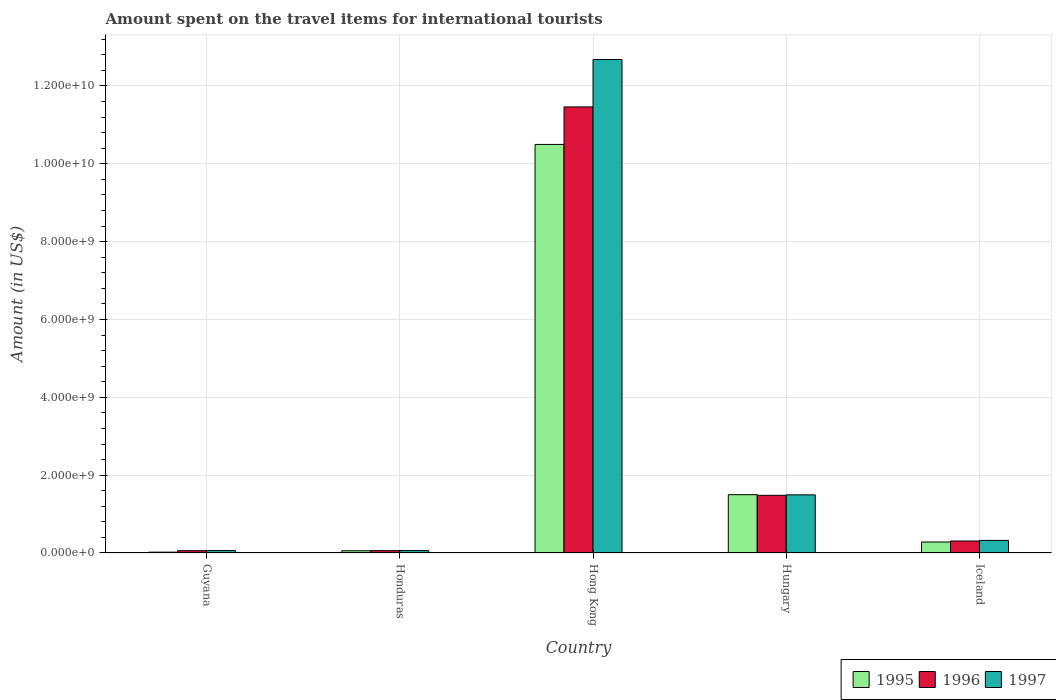How many different coloured bars are there?
Offer a terse response. 3. Are the number of bars on each tick of the X-axis equal?
Your answer should be compact. Yes. How many bars are there on the 4th tick from the left?
Make the answer very short. 3. How many bars are there on the 2nd tick from the right?
Ensure brevity in your answer.  3. What is the label of the 4th group of bars from the left?
Give a very brief answer. Hungary. What is the amount spent on the travel items for international tourists in 1996 in Hungary?
Offer a terse response. 1.48e+09. Across all countries, what is the maximum amount spent on the travel items for international tourists in 1997?
Offer a very short reply. 1.27e+1. Across all countries, what is the minimum amount spent on the travel items for international tourists in 1995?
Provide a short and direct response. 2.10e+07. In which country was the amount spent on the travel items for international tourists in 1996 maximum?
Keep it short and to the point. Hong Kong. In which country was the amount spent on the travel items for international tourists in 1995 minimum?
Your answer should be compact. Guyana. What is the total amount spent on the travel items for international tourists in 1997 in the graph?
Provide a succinct answer. 1.46e+1. What is the difference between the amount spent on the travel items for international tourists in 1996 in Hong Kong and that in Iceland?
Make the answer very short. 1.12e+1. What is the difference between the amount spent on the travel items for international tourists in 1995 in Iceland and the amount spent on the travel items for international tourists in 1996 in Hong Kong?
Your answer should be compact. -1.12e+1. What is the average amount spent on the travel items for international tourists in 1995 per country?
Your answer should be very brief. 2.47e+09. What is the difference between the amount spent on the travel items for international tourists of/in 1997 and amount spent on the travel items for international tourists of/in 1995 in Hungary?
Your answer should be compact. -4.00e+06. In how many countries, is the amount spent on the travel items for international tourists in 1995 greater than 4400000000 US$?
Provide a short and direct response. 1. What is the ratio of the amount spent on the travel items for international tourists in 1996 in Guyana to that in Honduras?
Keep it short and to the point. 0.98. Is the amount spent on the travel items for international tourists in 1995 in Honduras less than that in Hong Kong?
Ensure brevity in your answer.  Yes. What is the difference between the highest and the second highest amount spent on the travel items for international tourists in 1995?
Provide a short and direct response. 9.00e+09. What is the difference between the highest and the lowest amount spent on the travel items for international tourists in 1997?
Offer a terse response. 1.26e+1. In how many countries, is the amount spent on the travel items for international tourists in 1997 greater than the average amount spent on the travel items for international tourists in 1997 taken over all countries?
Offer a very short reply. 1. What does the 3rd bar from the left in Hong Kong represents?
Offer a very short reply. 1997. What does the 1st bar from the right in Guyana represents?
Provide a succinct answer. 1997. Are all the bars in the graph horizontal?
Your answer should be very brief. No. What is the difference between two consecutive major ticks on the Y-axis?
Keep it short and to the point. 2.00e+09. Does the graph contain any zero values?
Offer a terse response. No. Does the graph contain grids?
Offer a very short reply. Yes. What is the title of the graph?
Ensure brevity in your answer.  Amount spent on the travel items for international tourists. What is the Amount (in US$) of 1995 in Guyana?
Give a very brief answer. 2.10e+07. What is the Amount (in US$) of 1996 in Guyana?
Provide a short and direct response. 5.90e+07. What is the Amount (in US$) of 1997 in Guyana?
Your response must be concise. 6.20e+07. What is the Amount (in US$) in 1995 in Honduras?
Ensure brevity in your answer.  5.70e+07. What is the Amount (in US$) of 1996 in Honduras?
Keep it short and to the point. 6.00e+07. What is the Amount (in US$) in 1997 in Honduras?
Ensure brevity in your answer.  6.20e+07. What is the Amount (in US$) of 1995 in Hong Kong?
Give a very brief answer. 1.05e+1. What is the Amount (in US$) of 1996 in Hong Kong?
Your answer should be compact. 1.15e+1. What is the Amount (in US$) of 1997 in Hong Kong?
Keep it short and to the point. 1.27e+1. What is the Amount (in US$) in 1995 in Hungary?
Your answer should be compact. 1.50e+09. What is the Amount (in US$) of 1996 in Hungary?
Provide a succinct answer. 1.48e+09. What is the Amount (in US$) in 1997 in Hungary?
Keep it short and to the point. 1.49e+09. What is the Amount (in US$) of 1995 in Iceland?
Make the answer very short. 2.82e+08. What is the Amount (in US$) of 1996 in Iceland?
Make the answer very short. 3.08e+08. What is the Amount (in US$) in 1997 in Iceland?
Your response must be concise. 3.23e+08. Across all countries, what is the maximum Amount (in US$) in 1995?
Make the answer very short. 1.05e+1. Across all countries, what is the maximum Amount (in US$) of 1996?
Offer a very short reply. 1.15e+1. Across all countries, what is the maximum Amount (in US$) of 1997?
Your answer should be compact. 1.27e+1. Across all countries, what is the minimum Amount (in US$) in 1995?
Your response must be concise. 2.10e+07. Across all countries, what is the minimum Amount (in US$) of 1996?
Ensure brevity in your answer.  5.90e+07. Across all countries, what is the minimum Amount (in US$) of 1997?
Your answer should be compact. 6.20e+07. What is the total Amount (in US$) in 1995 in the graph?
Offer a very short reply. 1.24e+1. What is the total Amount (in US$) of 1996 in the graph?
Provide a short and direct response. 1.34e+1. What is the total Amount (in US$) in 1997 in the graph?
Your answer should be compact. 1.46e+1. What is the difference between the Amount (in US$) of 1995 in Guyana and that in Honduras?
Your answer should be compact. -3.60e+07. What is the difference between the Amount (in US$) in 1996 in Guyana and that in Honduras?
Ensure brevity in your answer.  -1.00e+06. What is the difference between the Amount (in US$) in 1995 in Guyana and that in Hong Kong?
Your response must be concise. -1.05e+1. What is the difference between the Amount (in US$) in 1996 in Guyana and that in Hong Kong?
Ensure brevity in your answer.  -1.14e+1. What is the difference between the Amount (in US$) of 1997 in Guyana and that in Hong Kong?
Give a very brief answer. -1.26e+1. What is the difference between the Amount (in US$) in 1995 in Guyana and that in Hungary?
Make the answer very short. -1.48e+09. What is the difference between the Amount (in US$) of 1996 in Guyana and that in Hungary?
Provide a short and direct response. -1.42e+09. What is the difference between the Amount (in US$) of 1997 in Guyana and that in Hungary?
Make the answer very short. -1.43e+09. What is the difference between the Amount (in US$) of 1995 in Guyana and that in Iceland?
Make the answer very short. -2.61e+08. What is the difference between the Amount (in US$) of 1996 in Guyana and that in Iceland?
Give a very brief answer. -2.49e+08. What is the difference between the Amount (in US$) of 1997 in Guyana and that in Iceland?
Your answer should be very brief. -2.61e+08. What is the difference between the Amount (in US$) in 1995 in Honduras and that in Hong Kong?
Ensure brevity in your answer.  -1.04e+1. What is the difference between the Amount (in US$) in 1996 in Honduras and that in Hong Kong?
Offer a terse response. -1.14e+1. What is the difference between the Amount (in US$) of 1997 in Honduras and that in Hong Kong?
Provide a short and direct response. -1.26e+1. What is the difference between the Amount (in US$) in 1995 in Honduras and that in Hungary?
Provide a short and direct response. -1.44e+09. What is the difference between the Amount (in US$) of 1996 in Honduras and that in Hungary?
Give a very brief answer. -1.42e+09. What is the difference between the Amount (in US$) of 1997 in Honduras and that in Hungary?
Your answer should be compact. -1.43e+09. What is the difference between the Amount (in US$) in 1995 in Honduras and that in Iceland?
Make the answer very short. -2.25e+08. What is the difference between the Amount (in US$) in 1996 in Honduras and that in Iceland?
Give a very brief answer. -2.48e+08. What is the difference between the Amount (in US$) of 1997 in Honduras and that in Iceland?
Give a very brief answer. -2.61e+08. What is the difference between the Amount (in US$) of 1995 in Hong Kong and that in Hungary?
Provide a short and direct response. 9.00e+09. What is the difference between the Amount (in US$) of 1996 in Hong Kong and that in Hungary?
Keep it short and to the point. 9.98e+09. What is the difference between the Amount (in US$) in 1997 in Hong Kong and that in Hungary?
Provide a short and direct response. 1.12e+1. What is the difference between the Amount (in US$) in 1995 in Hong Kong and that in Iceland?
Make the answer very short. 1.02e+1. What is the difference between the Amount (in US$) in 1996 in Hong Kong and that in Iceland?
Offer a terse response. 1.12e+1. What is the difference between the Amount (in US$) of 1997 in Hong Kong and that in Iceland?
Your response must be concise. 1.24e+1. What is the difference between the Amount (in US$) of 1995 in Hungary and that in Iceland?
Give a very brief answer. 1.22e+09. What is the difference between the Amount (in US$) in 1996 in Hungary and that in Iceland?
Make the answer very short. 1.17e+09. What is the difference between the Amount (in US$) of 1997 in Hungary and that in Iceland?
Your answer should be compact. 1.17e+09. What is the difference between the Amount (in US$) of 1995 in Guyana and the Amount (in US$) of 1996 in Honduras?
Make the answer very short. -3.90e+07. What is the difference between the Amount (in US$) of 1995 in Guyana and the Amount (in US$) of 1997 in Honduras?
Offer a terse response. -4.10e+07. What is the difference between the Amount (in US$) of 1996 in Guyana and the Amount (in US$) of 1997 in Honduras?
Offer a very short reply. -3.00e+06. What is the difference between the Amount (in US$) in 1995 in Guyana and the Amount (in US$) in 1996 in Hong Kong?
Provide a short and direct response. -1.14e+1. What is the difference between the Amount (in US$) of 1995 in Guyana and the Amount (in US$) of 1997 in Hong Kong?
Your answer should be compact. -1.27e+1. What is the difference between the Amount (in US$) of 1996 in Guyana and the Amount (in US$) of 1997 in Hong Kong?
Offer a very short reply. -1.26e+1. What is the difference between the Amount (in US$) in 1995 in Guyana and the Amount (in US$) in 1996 in Hungary?
Keep it short and to the point. -1.46e+09. What is the difference between the Amount (in US$) in 1995 in Guyana and the Amount (in US$) in 1997 in Hungary?
Provide a succinct answer. -1.47e+09. What is the difference between the Amount (in US$) of 1996 in Guyana and the Amount (in US$) of 1997 in Hungary?
Provide a succinct answer. -1.44e+09. What is the difference between the Amount (in US$) of 1995 in Guyana and the Amount (in US$) of 1996 in Iceland?
Make the answer very short. -2.87e+08. What is the difference between the Amount (in US$) in 1995 in Guyana and the Amount (in US$) in 1997 in Iceland?
Ensure brevity in your answer.  -3.02e+08. What is the difference between the Amount (in US$) in 1996 in Guyana and the Amount (in US$) in 1997 in Iceland?
Ensure brevity in your answer.  -2.64e+08. What is the difference between the Amount (in US$) in 1995 in Honduras and the Amount (in US$) in 1996 in Hong Kong?
Provide a short and direct response. -1.14e+1. What is the difference between the Amount (in US$) of 1995 in Honduras and the Amount (in US$) of 1997 in Hong Kong?
Your answer should be compact. -1.26e+1. What is the difference between the Amount (in US$) of 1996 in Honduras and the Amount (in US$) of 1997 in Hong Kong?
Provide a short and direct response. -1.26e+1. What is the difference between the Amount (in US$) of 1995 in Honduras and the Amount (in US$) of 1996 in Hungary?
Make the answer very short. -1.42e+09. What is the difference between the Amount (in US$) of 1995 in Honduras and the Amount (in US$) of 1997 in Hungary?
Offer a very short reply. -1.44e+09. What is the difference between the Amount (in US$) of 1996 in Honduras and the Amount (in US$) of 1997 in Hungary?
Give a very brief answer. -1.43e+09. What is the difference between the Amount (in US$) of 1995 in Honduras and the Amount (in US$) of 1996 in Iceland?
Keep it short and to the point. -2.51e+08. What is the difference between the Amount (in US$) in 1995 in Honduras and the Amount (in US$) in 1997 in Iceland?
Ensure brevity in your answer.  -2.66e+08. What is the difference between the Amount (in US$) in 1996 in Honduras and the Amount (in US$) in 1997 in Iceland?
Your answer should be compact. -2.63e+08. What is the difference between the Amount (in US$) in 1995 in Hong Kong and the Amount (in US$) in 1996 in Hungary?
Give a very brief answer. 9.02e+09. What is the difference between the Amount (in US$) in 1995 in Hong Kong and the Amount (in US$) in 1997 in Hungary?
Give a very brief answer. 9.00e+09. What is the difference between the Amount (in US$) of 1996 in Hong Kong and the Amount (in US$) of 1997 in Hungary?
Make the answer very short. 9.97e+09. What is the difference between the Amount (in US$) of 1995 in Hong Kong and the Amount (in US$) of 1996 in Iceland?
Keep it short and to the point. 1.02e+1. What is the difference between the Amount (in US$) in 1995 in Hong Kong and the Amount (in US$) in 1997 in Iceland?
Your answer should be compact. 1.02e+1. What is the difference between the Amount (in US$) of 1996 in Hong Kong and the Amount (in US$) of 1997 in Iceland?
Provide a short and direct response. 1.11e+1. What is the difference between the Amount (in US$) in 1995 in Hungary and the Amount (in US$) in 1996 in Iceland?
Make the answer very short. 1.19e+09. What is the difference between the Amount (in US$) of 1995 in Hungary and the Amount (in US$) of 1997 in Iceland?
Offer a very short reply. 1.18e+09. What is the difference between the Amount (in US$) of 1996 in Hungary and the Amount (in US$) of 1997 in Iceland?
Offer a very short reply. 1.16e+09. What is the average Amount (in US$) in 1995 per country?
Your answer should be very brief. 2.47e+09. What is the average Amount (in US$) in 1996 per country?
Your response must be concise. 2.67e+09. What is the average Amount (in US$) of 1997 per country?
Keep it short and to the point. 2.92e+09. What is the difference between the Amount (in US$) of 1995 and Amount (in US$) of 1996 in Guyana?
Your answer should be compact. -3.80e+07. What is the difference between the Amount (in US$) in 1995 and Amount (in US$) in 1997 in Guyana?
Make the answer very short. -4.10e+07. What is the difference between the Amount (in US$) in 1996 and Amount (in US$) in 1997 in Guyana?
Keep it short and to the point. -3.00e+06. What is the difference between the Amount (in US$) in 1995 and Amount (in US$) in 1996 in Honduras?
Provide a succinct answer. -3.00e+06. What is the difference between the Amount (in US$) of 1995 and Amount (in US$) of 1997 in Honduras?
Give a very brief answer. -5.00e+06. What is the difference between the Amount (in US$) in 1996 and Amount (in US$) in 1997 in Honduras?
Offer a terse response. -2.00e+06. What is the difference between the Amount (in US$) in 1995 and Amount (in US$) in 1996 in Hong Kong?
Provide a succinct answer. -9.64e+08. What is the difference between the Amount (in US$) of 1995 and Amount (in US$) of 1997 in Hong Kong?
Offer a terse response. -2.18e+09. What is the difference between the Amount (in US$) in 1996 and Amount (in US$) in 1997 in Hong Kong?
Ensure brevity in your answer.  -1.22e+09. What is the difference between the Amount (in US$) of 1995 and Amount (in US$) of 1996 in Hungary?
Ensure brevity in your answer.  1.60e+07. What is the difference between the Amount (in US$) of 1996 and Amount (in US$) of 1997 in Hungary?
Give a very brief answer. -1.20e+07. What is the difference between the Amount (in US$) in 1995 and Amount (in US$) in 1996 in Iceland?
Keep it short and to the point. -2.60e+07. What is the difference between the Amount (in US$) in 1995 and Amount (in US$) in 1997 in Iceland?
Keep it short and to the point. -4.10e+07. What is the difference between the Amount (in US$) in 1996 and Amount (in US$) in 1997 in Iceland?
Offer a very short reply. -1.50e+07. What is the ratio of the Amount (in US$) of 1995 in Guyana to that in Honduras?
Keep it short and to the point. 0.37. What is the ratio of the Amount (in US$) of 1996 in Guyana to that in Honduras?
Give a very brief answer. 0.98. What is the ratio of the Amount (in US$) in 1997 in Guyana to that in Honduras?
Offer a very short reply. 1. What is the ratio of the Amount (in US$) in 1995 in Guyana to that in Hong Kong?
Give a very brief answer. 0. What is the ratio of the Amount (in US$) of 1996 in Guyana to that in Hong Kong?
Give a very brief answer. 0.01. What is the ratio of the Amount (in US$) in 1997 in Guyana to that in Hong Kong?
Offer a terse response. 0. What is the ratio of the Amount (in US$) of 1995 in Guyana to that in Hungary?
Offer a terse response. 0.01. What is the ratio of the Amount (in US$) of 1996 in Guyana to that in Hungary?
Offer a terse response. 0.04. What is the ratio of the Amount (in US$) of 1997 in Guyana to that in Hungary?
Offer a very short reply. 0.04. What is the ratio of the Amount (in US$) of 1995 in Guyana to that in Iceland?
Your answer should be compact. 0.07. What is the ratio of the Amount (in US$) in 1996 in Guyana to that in Iceland?
Keep it short and to the point. 0.19. What is the ratio of the Amount (in US$) of 1997 in Guyana to that in Iceland?
Your response must be concise. 0.19. What is the ratio of the Amount (in US$) of 1995 in Honduras to that in Hong Kong?
Provide a short and direct response. 0.01. What is the ratio of the Amount (in US$) of 1996 in Honduras to that in Hong Kong?
Offer a terse response. 0.01. What is the ratio of the Amount (in US$) in 1997 in Honduras to that in Hong Kong?
Give a very brief answer. 0. What is the ratio of the Amount (in US$) in 1995 in Honduras to that in Hungary?
Your response must be concise. 0.04. What is the ratio of the Amount (in US$) of 1996 in Honduras to that in Hungary?
Offer a terse response. 0.04. What is the ratio of the Amount (in US$) of 1997 in Honduras to that in Hungary?
Provide a short and direct response. 0.04. What is the ratio of the Amount (in US$) of 1995 in Honduras to that in Iceland?
Provide a succinct answer. 0.2. What is the ratio of the Amount (in US$) in 1996 in Honduras to that in Iceland?
Your response must be concise. 0.19. What is the ratio of the Amount (in US$) of 1997 in Honduras to that in Iceland?
Your response must be concise. 0.19. What is the ratio of the Amount (in US$) of 1995 in Hong Kong to that in Hungary?
Provide a short and direct response. 7.01. What is the ratio of the Amount (in US$) of 1996 in Hong Kong to that in Hungary?
Provide a short and direct response. 7.73. What is the ratio of the Amount (in US$) of 1997 in Hong Kong to that in Hungary?
Your answer should be very brief. 8.49. What is the ratio of the Amount (in US$) in 1995 in Hong Kong to that in Iceland?
Offer a terse response. 37.22. What is the ratio of the Amount (in US$) of 1996 in Hong Kong to that in Iceland?
Make the answer very short. 37.21. What is the ratio of the Amount (in US$) of 1997 in Hong Kong to that in Iceland?
Your answer should be very brief. 39.25. What is the ratio of the Amount (in US$) in 1995 in Hungary to that in Iceland?
Provide a succinct answer. 5.31. What is the ratio of the Amount (in US$) of 1996 in Hungary to that in Iceland?
Make the answer very short. 4.81. What is the ratio of the Amount (in US$) of 1997 in Hungary to that in Iceland?
Your response must be concise. 4.63. What is the difference between the highest and the second highest Amount (in US$) of 1995?
Keep it short and to the point. 9.00e+09. What is the difference between the highest and the second highest Amount (in US$) of 1996?
Keep it short and to the point. 9.98e+09. What is the difference between the highest and the second highest Amount (in US$) in 1997?
Make the answer very short. 1.12e+1. What is the difference between the highest and the lowest Amount (in US$) in 1995?
Your answer should be very brief. 1.05e+1. What is the difference between the highest and the lowest Amount (in US$) of 1996?
Keep it short and to the point. 1.14e+1. What is the difference between the highest and the lowest Amount (in US$) of 1997?
Give a very brief answer. 1.26e+1. 